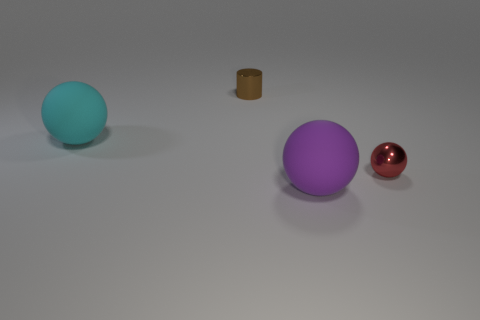Subtract all matte spheres. How many spheres are left? 1 Add 2 small gray objects. How many objects exist? 6 Subtract all cylinders. How many objects are left? 3 Subtract 2 balls. How many balls are left? 1 Subtract all purple spheres. How many spheres are left? 2 Subtract 0 cyan cubes. How many objects are left? 4 Subtract all yellow spheres. Subtract all purple cubes. How many spheres are left? 3 Subtract all brown cubes. How many red balls are left? 1 Subtract all small metallic cylinders. Subtract all rubber spheres. How many objects are left? 1 Add 4 small metal objects. How many small metal objects are left? 6 